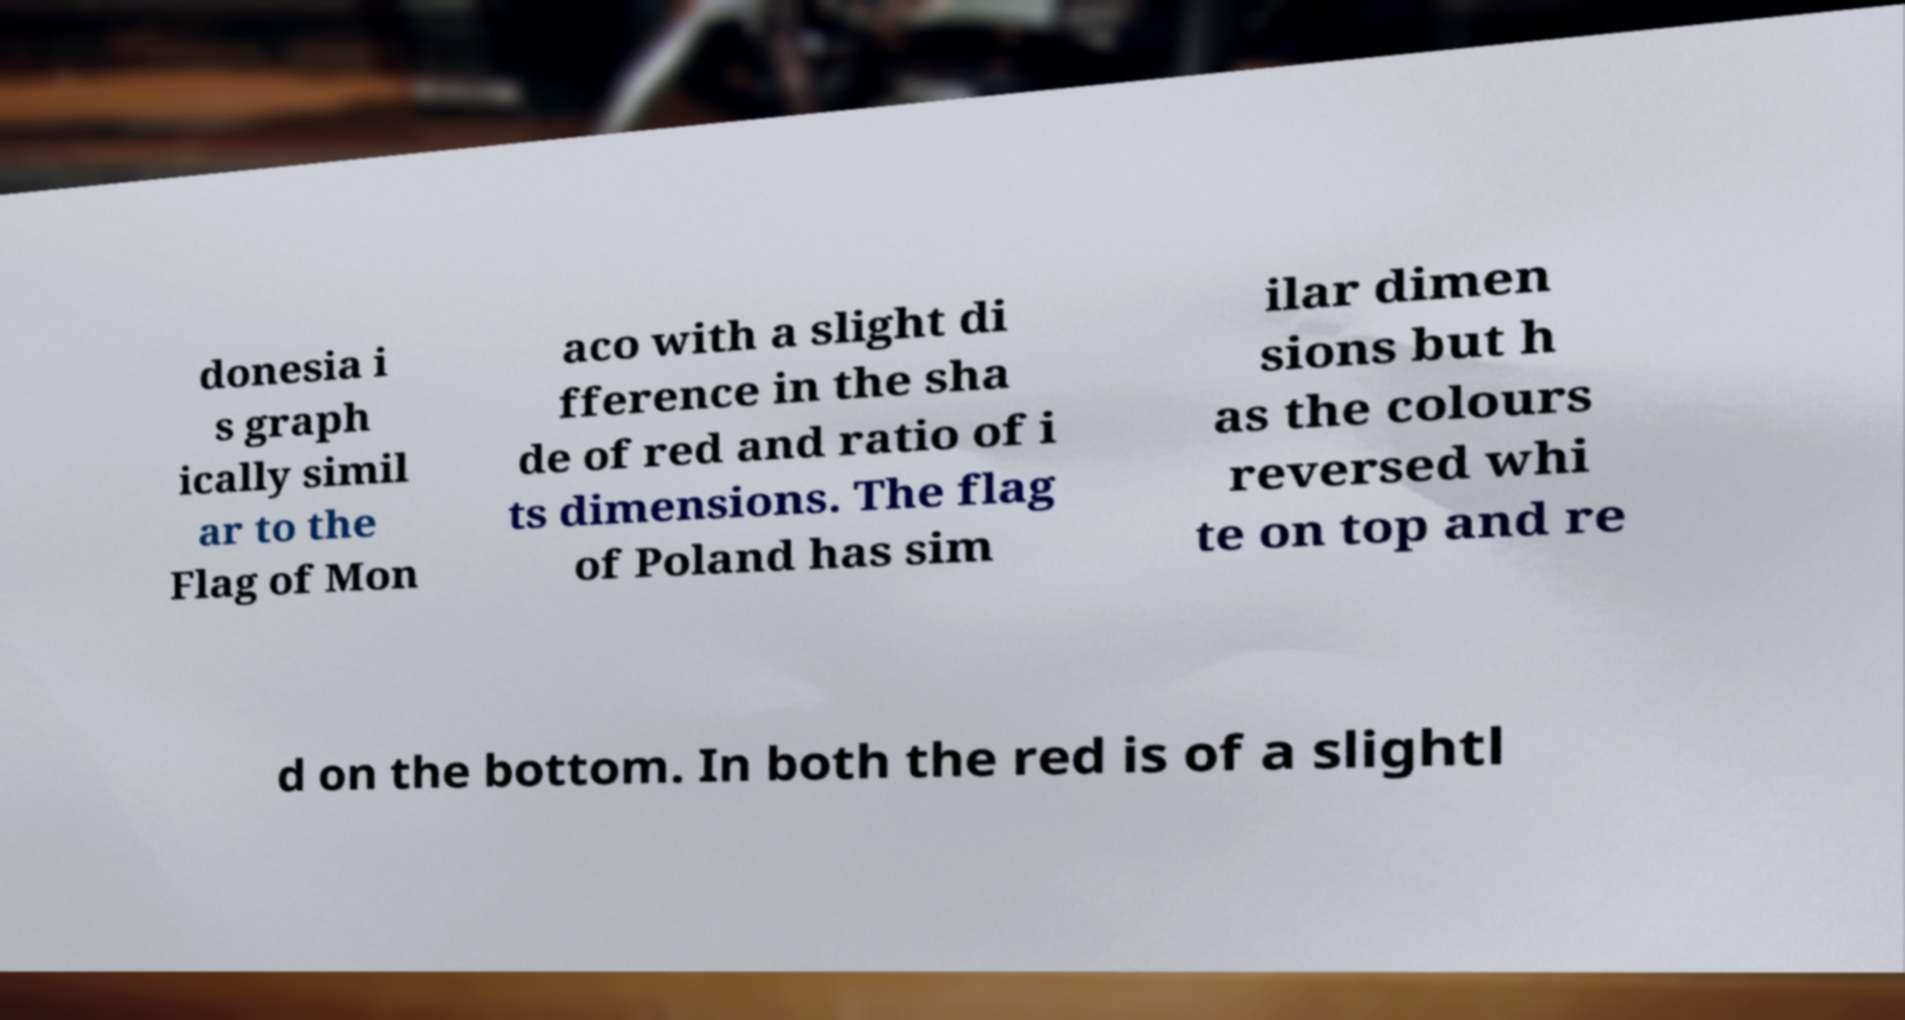There's text embedded in this image that I need extracted. Can you transcribe it verbatim? donesia i s graph ically simil ar to the Flag of Mon aco with a slight di fference in the sha de of red and ratio of i ts dimensions. The flag of Poland has sim ilar dimen sions but h as the colours reversed whi te on top and re d on the bottom. In both the red is of a slightl 